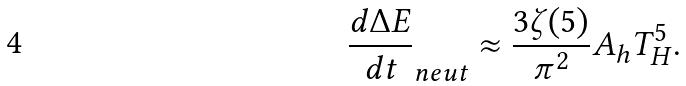Convert formula to latex. <formula><loc_0><loc_0><loc_500><loc_500>\frac { d \Delta E } { d t } _ { n e u t } \approx \frac { 3 \zeta ( 5 ) } { \pi ^ { 2 } } A _ { h } T _ { H } ^ { 5 } .</formula> 